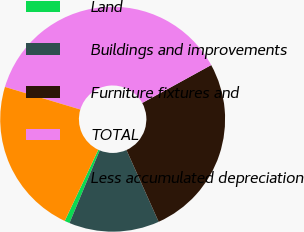<chart> <loc_0><loc_0><loc_500><loc_500><pie_chart><fcel>Land<fcel>Buildings and improvements<fcel>Furniture fixtures and<fcel>TOTAL<fcel>Less accumulated depreciation<nl><fcel>0.74%<fcel>12.98%<fcel>26.29%<fcel>37.37%<fcel>22.63%<nl></chart> 